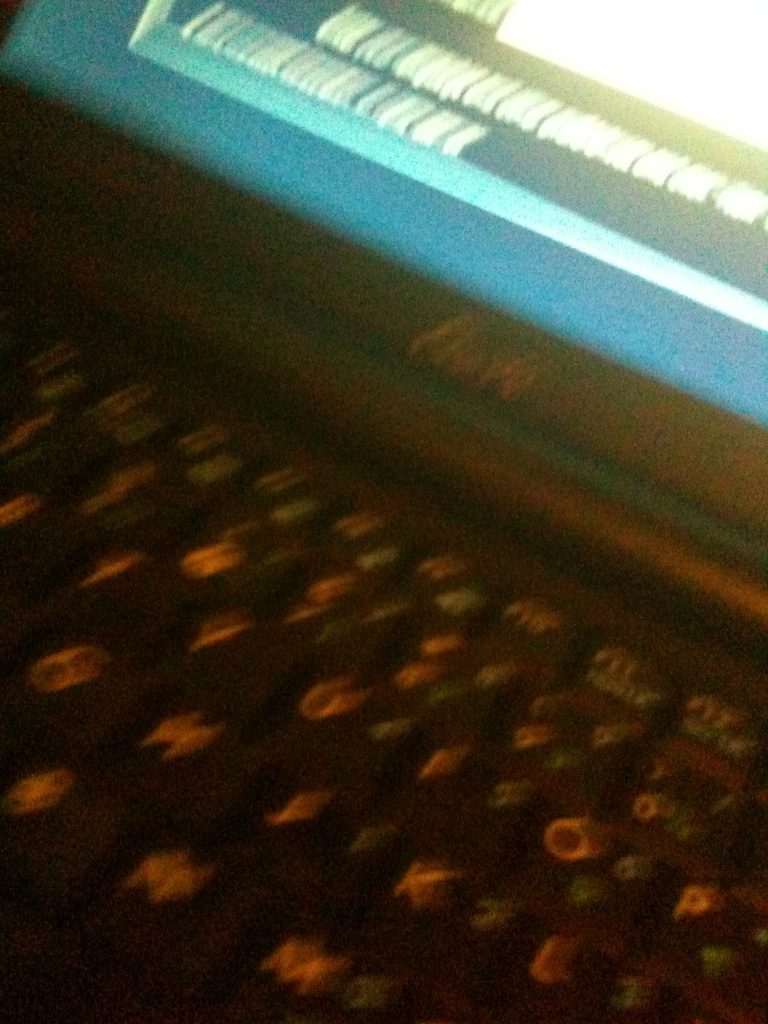Would it help if there was more light I wonder or is it just because this camera is so bad? Improving the lighting might indeed help enhance the image quality, as better illumination can compensate for some weaknesses in the camera's sensor. Additionally, using a higher resolution setting or steadying the camera could also improve clarity. 